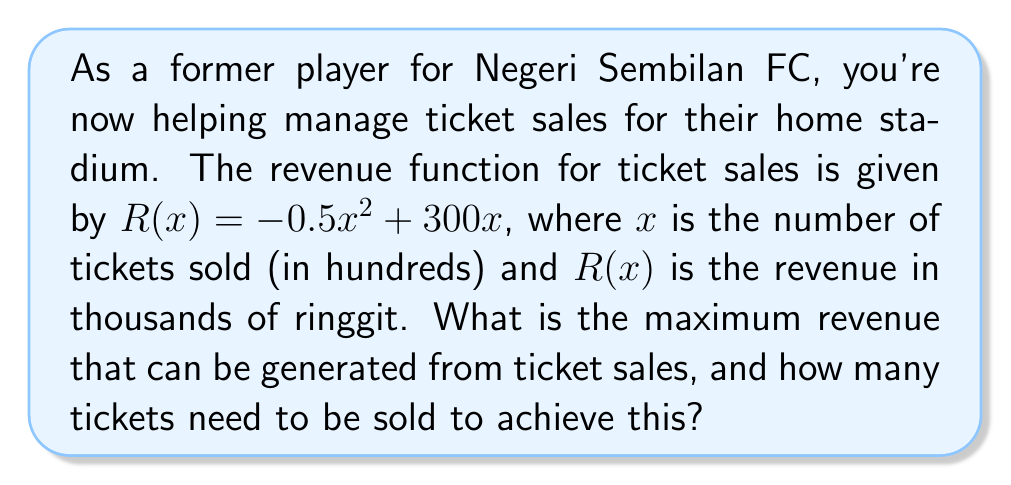Give your solution to this math problem. To find the maximum revenue, we need to follow these steps:

1) The revenue function is a quadratic function: $R(x) = -0.5x^2 + 300x$

2) To find the maximum point, we need to find the vertex of this parabola. For a quadratic function in the form $f(x) = ax^2 + bx + c$, the x-coordinate of the vertex is given by $x = -\frac{b}{2a}$

3) In our case, $a = -0.5$ and $b = 300$. So:

   $x = -\frac{300}{2(-0.5)} = -\frac{300}{-1} = 300$

4) This means the maximum revenue occurs when 300 hundred tickets are sold, or 30,000 tickets.

5) To find the maximum revenue, we substitute this x-value back into our original function:

   $R(300) = -0.5(300)^2 + 300(300)$
           $= -0.5(90,000) + 90,000$
           $= -45,000 + 90,000$
           $= 45,000$

6) Therefore, the maximum revenue is 45,000 thousand ringgit, or 45 million ringgit.
Answer: 45 million ringgit when 30,000 tickets are sold. 